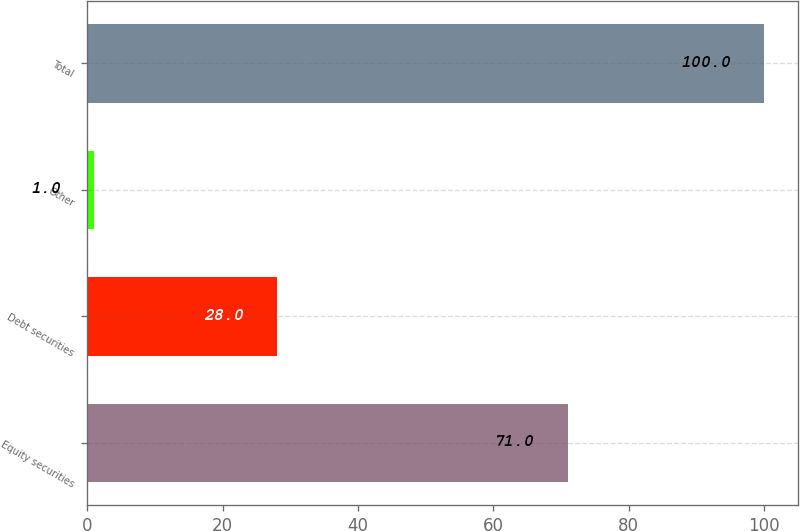<chart> <loc_0><loc_0><loc_500><loc_500><bar_chart><fcel>Equity securities<fcel>Debt securities<fcel>Other<fcel>Total<nl><fcel>71<fcel>28<fcel>1<fcel>100<nl></chart> 